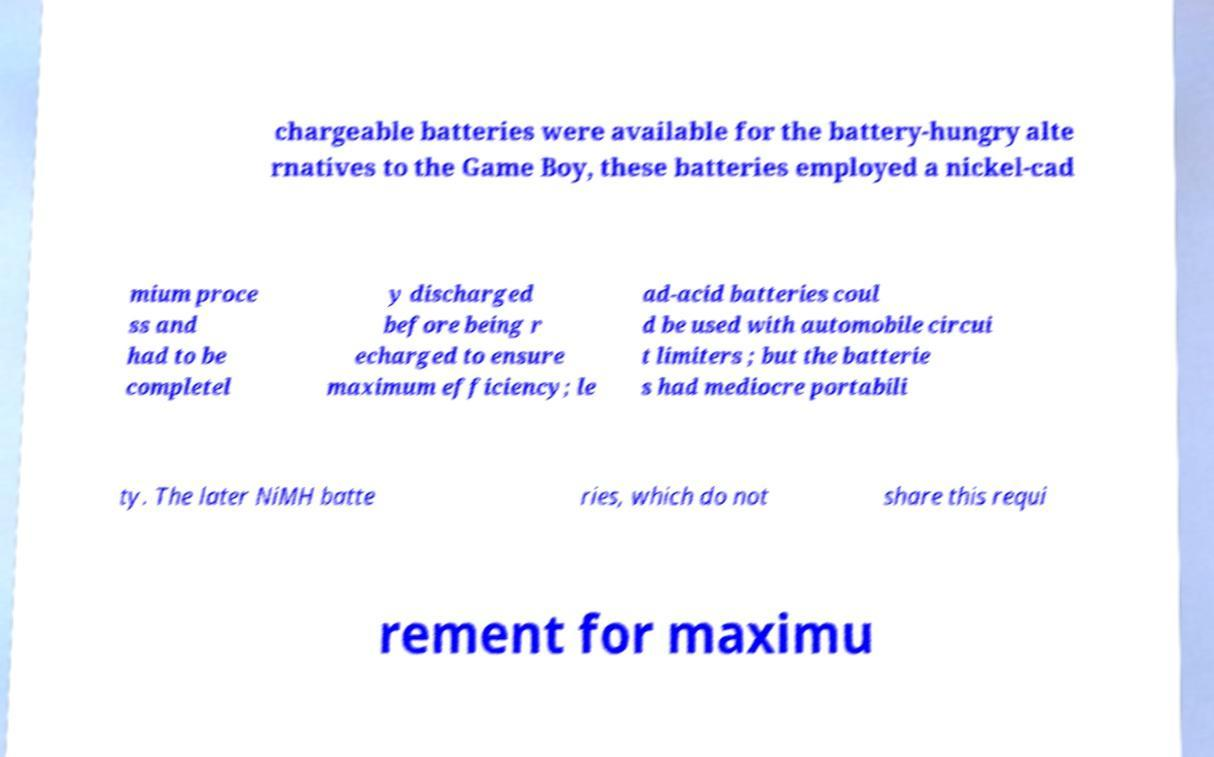Please read and relay the text visible in this image. What does it say? chargeable batteries were available for the battery-hungry alte rnatives to the Game Boy, these batteries employed a nickel-cad mium proce ss and had to be completel y discharged before being r echarged to ensure maximum efficiency; le ad-acid batteries coul d be used with automobile circui t limiters ; but the batterie s had mediocre portabili ty. The later NiMH batte ries, which do not share this requi rement for maximu 